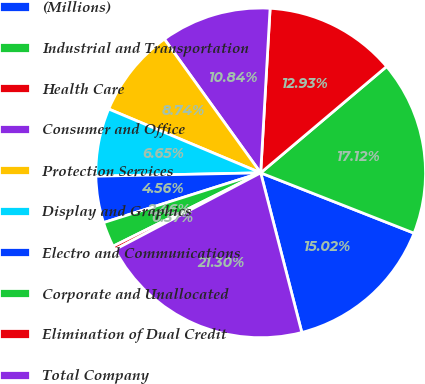Convert chart to OTSL. <chart><loc_0><loc_0><loc_500><loc_500><pie_chart><fcel>(Millions)<fcel>Industrial and Transportation<fcel>Health Care<fcel>Consumer and Office<fcel>Protection Services<fcel>Display and Graphics<fcel>Electro and Communications<fcel>Corporate and Unallocated<fcel>Elimination of Dual Credit<fcel>Total Company<nl><fcel>15.02%<fcel>17.12%<fcel>12.93%<fcel>10.84%<fcel>8.74%<fcel>6.65%<fcel>4.56%<fcel>2.46%<fcel>0.37%<fcel>21.3%<nl></chart> 